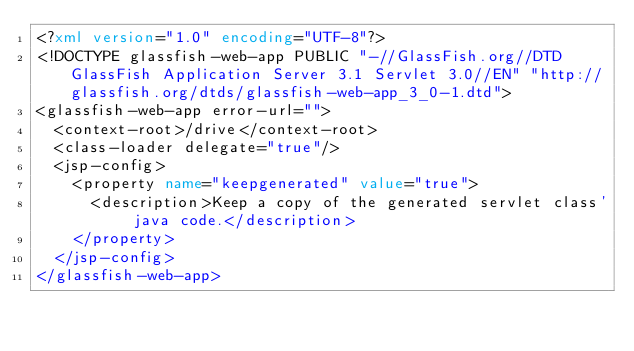<code> <loc_0><loc_0><loc_500><loc_500><_XML_><?xml version="1.0" encoding="UTF-8"?>
<!DOCTYPE glassfish-web-app PUBLIC "-//GlassFish.org//DTD GlassFish Application Server 3.1 Servlet 3.0//EN" "http://glassfish.org/dtds/glassfish-web-app_3_0-1.dtd">
<glassfish-web-app error-url="">
  <context-root>/drive</context-root>
  <class-loader delegate="true"/>
  <jsp-config>
    <property name="keepgenerated" value="true">
      <description>Keep a copy of the generated servlet class' java code.</description>
    </property>
  </jsp-config>
</glassfish-web-app>
</code> 